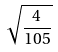<formula> <loc_0><loc_0><loc_500><loc_500>\sqrt { \frac { 4 } { 1 0 5 } }</formula> 